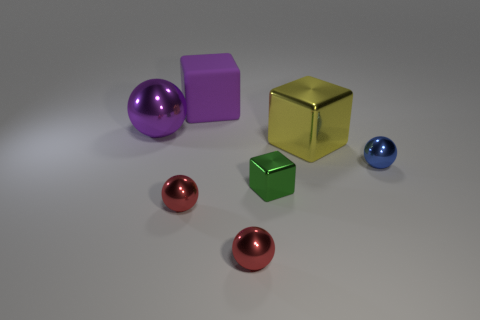Subtract all small spheres. How many spheres are left? 1 Add 1 tiny metallic spheres. How many objects exist? 8 Subtract all yellow blocks. How many blocks are left? 2 Subtract all blocks. How many objects are left? 4 Subtract 2 cubes. How many cubes are left? 1 Subtract all yellow cylinders. How many yellow cubes are left? 1 Subtract all tiny blue metal balls. Subtract all big shiny things. How many objects are left? 4 Add 2 tiny red metallic objects. How many tiny red metallic objects are left? 4 Add 2 large purple spheres. How many large purple spheres exist? 3 Subtract 1 green cubes. How many objects are left? 6 